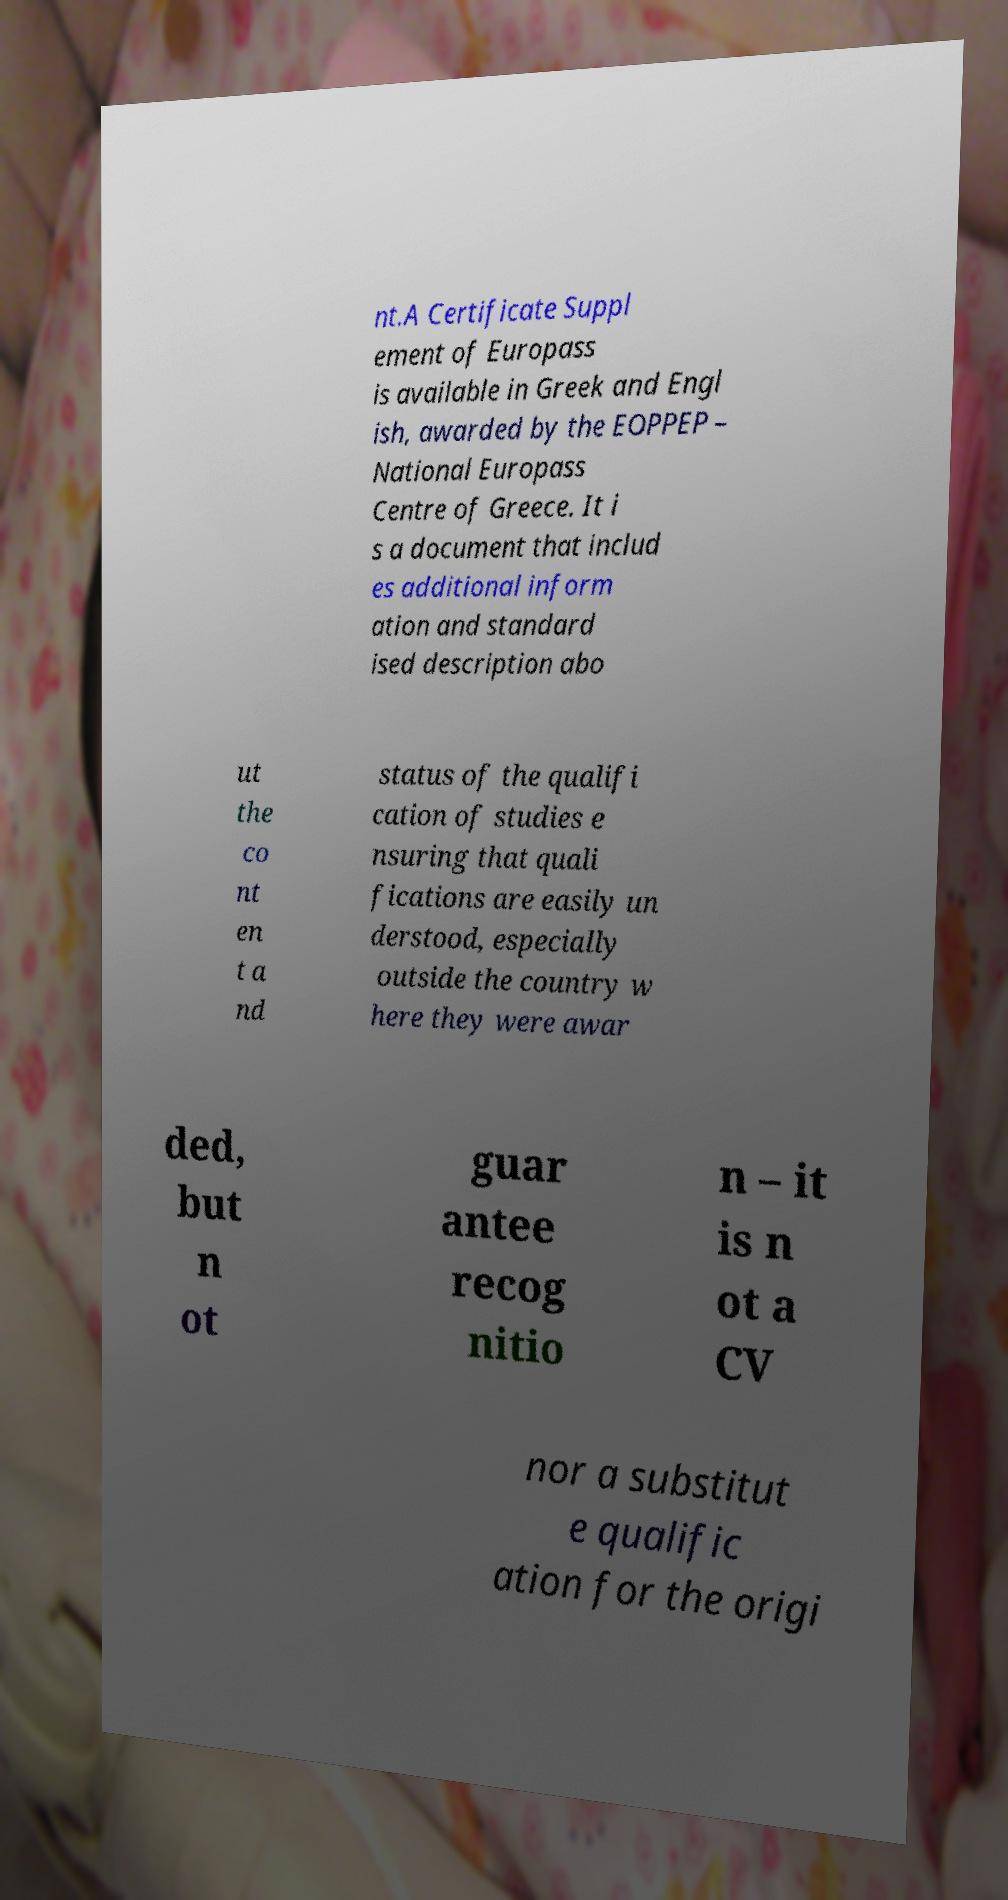Please read and relay the text visible in this image. What does it say? nt.A Certificate Suppl ement of Europass is available in Greek and Engl ish, awarded by the EOPPEP – National Europass Centre of Greece. It i s a document that includ es additional inform ation and standard ised description abo ut the co nt en t a nd status of the qualifi cation of studies e nsuring that quali fications are easily un derstood, especially outside the country w here they were awar ded, but n ot guar antee recog nitio n – it is n ot a CV nor a substitut e qualific ation for the origi 